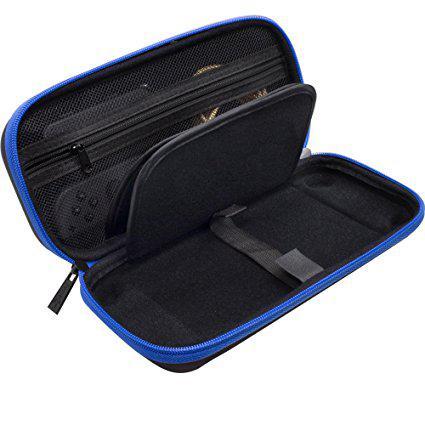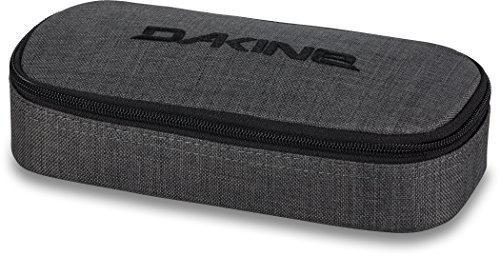The first image is the image on the left, the second image is the image on the right. For the images displayed, is the sentence "One bag is unzipped." factually correct? Answer yes or no. Yes. The first image is the image on the left, the second image is the image on the right. Examine the images to the left and right. Is the description "A pouch is unzipped  and open in one of the images." accurate? Answer yes or no. Yes. 